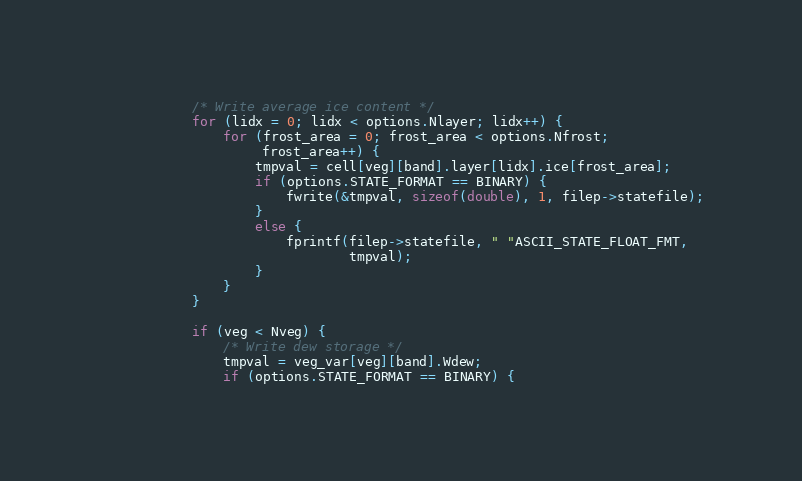<code> <loc_0><loc_0><loc_500><loc_500><_C_>            /* Write average ice content */
            for (lidx = 0; lidx < options.Nlayer; lidx++) {
                for (frost_area = 0; frost_area < options.Nfrost;
                     frost_area++) {
                    tmpval = cell[veg][band].layer[lidx].ice[frost_area];
                    if (options.STATE_FORMAT == BINARY) {
                        fwrite(&tmpval, sizeof(double), 1, filep->statefile);
                    }
                    else {
                        fprintf(filep->statefile, " "ASCII_STATE_FLOAT_FMT,
                                tmpval);
                    }
                }
            }

            if (veg < Nveg) {
                /* Write dew storage */
                tmpval = veg_var[veg][band].Wdew;
                if (options.STATE_FORMAT == BINARY) {</code> 